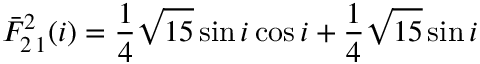<formula> <loc_0><loc_0><loc_500><loc_500>\bar { F } _ { 2 \, 1 } ^ { 2 } ( i ) = \frac { 1 } { 4 } \sqrt { 1 5 } \sin i \cos i + \frac { 1 } { 4 } \sqrt { 1 5 } \sin i</formula> 